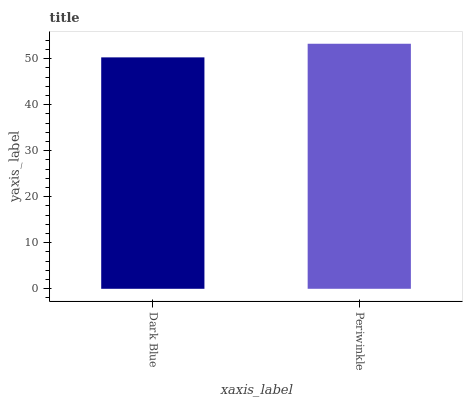Is Periwinkle the minimum?
Answer yes or no. No. Is Periwinkle greater than Dark Blue?
Answer yes or no. Yes. Is Dark Blue less than Periwinkle?
Answer yes or no. Yes. Is Dark Blue greater than Periwinkle?
Answer yes or no. No. Is Periwinkle less than Dark Blue?
Answer yes or no. No. Is Periwinkle the high median?
Answer yes or no. Yes. Is Dark Blue the low median?
Answer yes or no. Yes. Is Dark Blue the high median?
Answer yes or no. No. Is Periwinkle the low median?
Answer yes or no. No. 